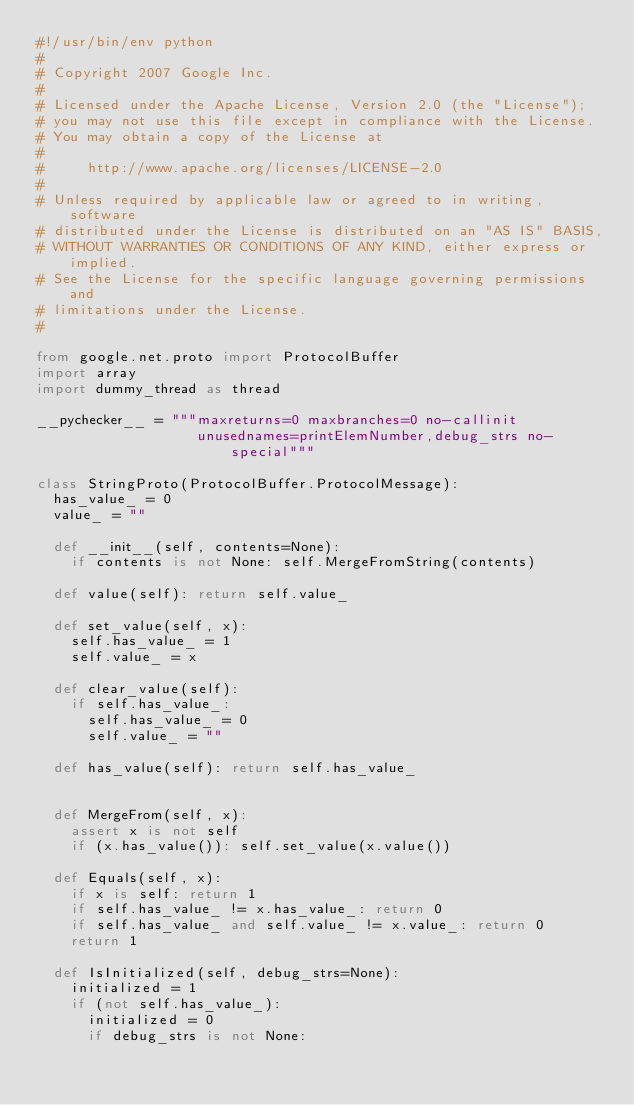Convert code to text. <code><loc_0><loc_0><loc_500><loc_500><_Python_>#!/usr/bin/env python
#
# Copyright 2007 Google Inc.
#
# Licensed under the Apache License, Version 2.0 (the "License");
# you may not use this file except in compliance with the License.
# You may obtain a copy of the License at
#
#     http://www.apache.org/licenses/LICENSE-2.0
#
# Unless required by applicable law or agreed to in writing, software
# distributed under the License is distributed on an "AS IS" BASIS,
# WITHOUT WARRANTIES OR CONDITIONS OF ANY KIND, either express or implied.
# See the License for the specific language governing permissions and
# limitations under the License.
#

from google.net.proto import ProtocolBuffer
import array
import dummy_thread as thread

__pychecker__ = """maxreturns=0 maxbranches=0 no-callinit
                   unusednames=printElemNumber,debug_strs no-special"""

class StringProto(ProtocolBuffer.ProtocolMessage):
  has_value_ = 0
  value_ = ""

  def __init__(self, contents=None):
    if contents is not None: self.MergeFromString(contents)

  def value(self): return self.value_

  def set_value(self, x):
    self.has_value_ = 1
    self.value_ = x

  def clear_value(self):
    if self.has_value_:
      self.has_value_ = 0
      self.value_ = ""

  def has_value(self): return self.has_value_


  def MergeFrom(self, x):
    assert x is not self
    if (x.has_value()): self.set_value(x.value())

  def Equals(self, x):
    if x is self: return 1
    if self.has_value_ != x.has_value_: return 0
    if self.has_value_ and self.value_ != x.value_: return 0
    return 1

  def IsInitialized(self, debug_strs=None):
    initialized = 1
    if (not self.has_value_):
      initialized = 0
      if debug_strs is not None:</code> 